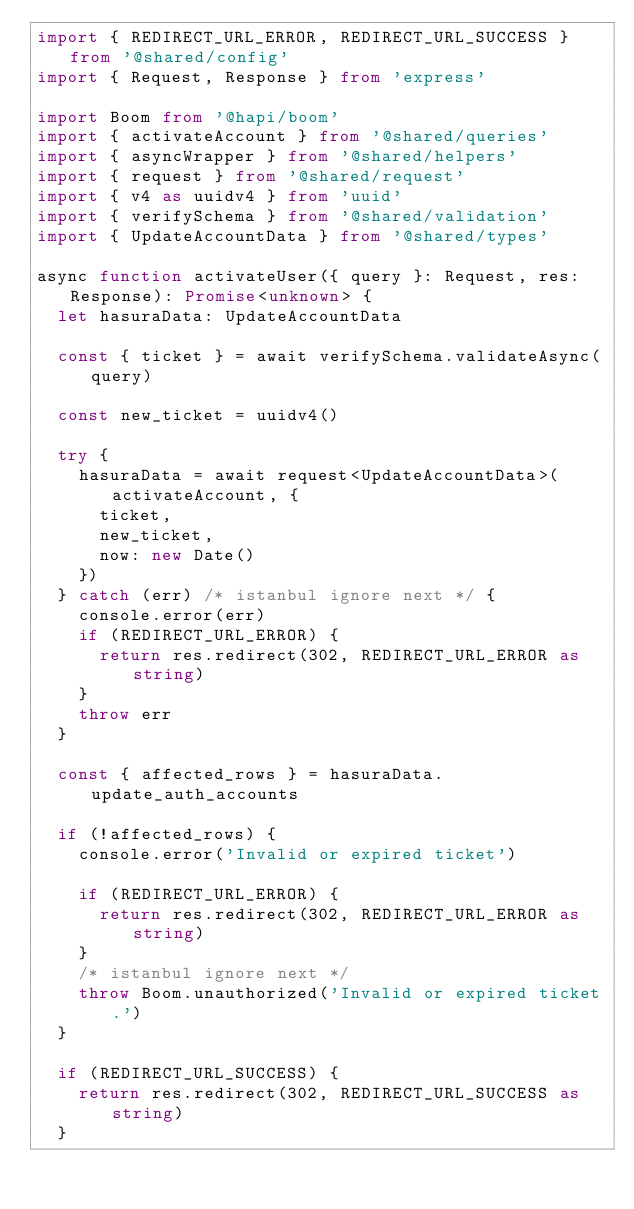<code> <loc_0><loc_0><loc_500><loc_500><_TypeScript_>import { REDIRECT_URL_ERROR, REDIRECT_URL_SUCCESS } from '@shared/config'
import { Request, Response } from 'express'

import Boom from '@hapi/boom'
import { activateAccount } from '@shared/queries'
import { asyncWrapper } from '@shared/helpers'
import { request } from '@shared/request'
import { v4 as uuidv4 } from 'uuid'
import { verifySchema } from '@shared/validation'
import { UpdateAccountData } from '@shared/types'

async function activateUser({ query }: Request, res: Response): Promise<unknown> {
  let hasuraData: UpdateAccountData

  const { ticket } = await verifySchema.validateAsync(query)

  const new_ticket = uuidv4()

  try {
    hasuraData = await request<UpdateAccountData>(activateAccount, {
      ticket,
      new_ticket,
      now: new Date()
    })
  } catch (err) /* istanbul ignore next */ {
    console.error(err)
    if (REDIRECT_URL_ERROR) {
      return res.redirect(302, REDIRECT_URL_ERROR as string)
    }
    throw err
  }

  const { affected_rows } = hasuraData.update_auth_accounts

  if (!affected_rows) {
    console.error('Invalid or expired ticket')

    if (REDIRECT_URL_ERROR) {
      return res.redirect(302, REDIRECT_URL_ERROR as string)
    }
    /* istanbul ignore next */
    throw Boom.unauthorized('Invalid or expired ticket.')
  }

  if (REDIRECT_URL_SUCCESS) {
    return res.redirect(302, REDIRECT_URL_SUCCESS as string)
  }
</code> 